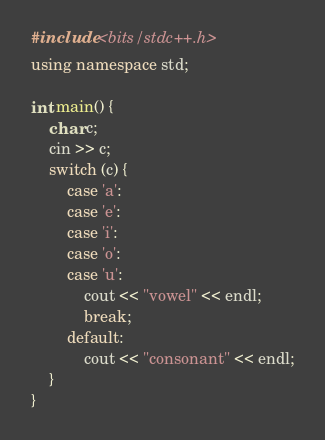Convert code to text. <code><loc_0><loc_0><loc_500><loc_500><_C++_>#include <bits/stdc++.h>
using namespace std;

int main() {
	char c;
	cin >> c;
	switch (c) {
		case 'a':
		case 'e':
		case 'i':
		case 'o':
		case 'u':
			cout << "vowel" << endl;
			break;
		default:
			cout << "consonant" << endl;
	}
}</code> 